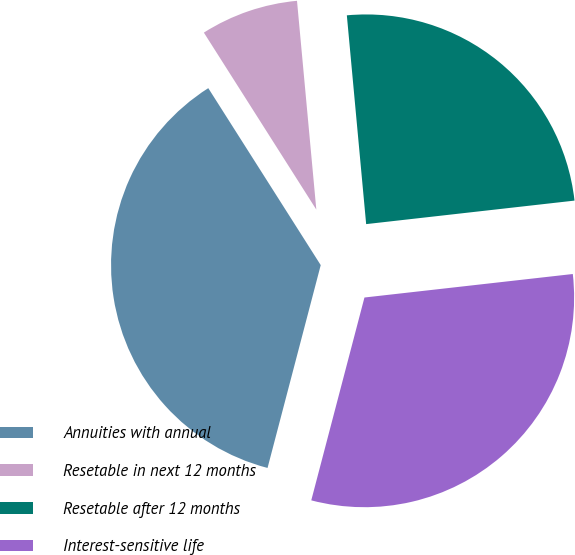<chart> <loc_0><loc_0><loc_500><loc_500><pie_chart><fcel>Annuities with annual<fcel>Resetable in next 12 months<fcel>Resetable after 12 months<fcel>Interest-sensitive life<nl><fcel>36.91%<fcel>7.54%<fcel>24.68%<fcel>30.87%<nl></chart> 